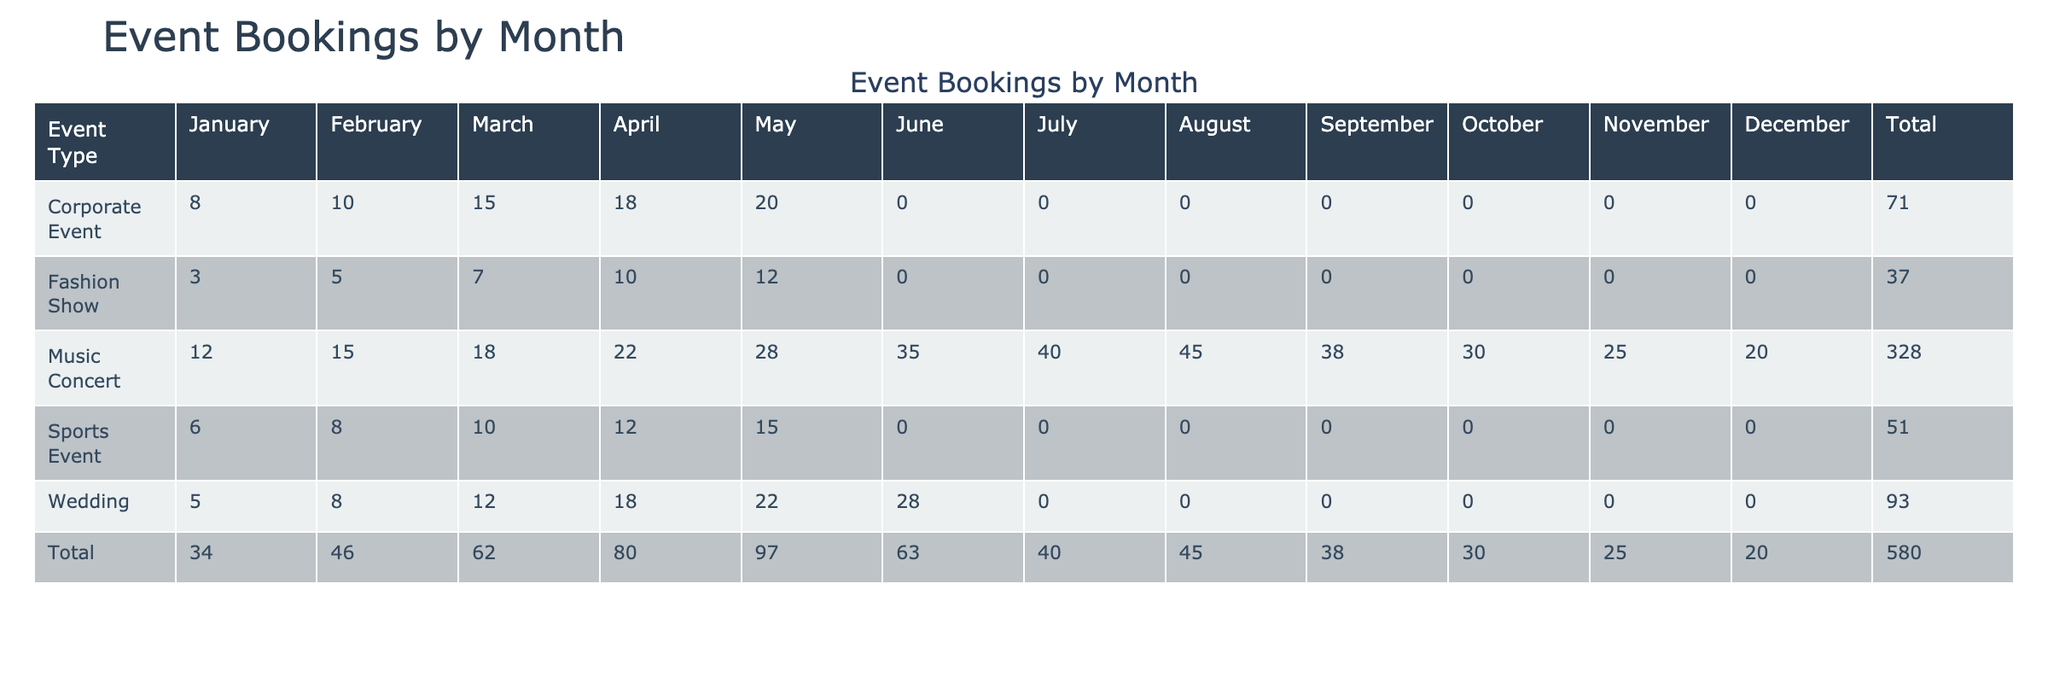What is the total number of bookings for music concerts in June? The table shows that in June, there were 35 bookings for music concerts listed under that month.
Answer: 35 Which event type had the highest total revenue across all months? By summing the revenue for each event type, we find that music concerts generated the most revenue, totaling 365,000, compared to weddings (225,000), corporate events (204,000), fashion shows (94,000), and sports events (77,000).
Answer: Music Concert How many more bookings were there for music concerts than weddings in October? In October, music concerts had 30 bookings, while weddings had 0. The difference is 30 - 0 = 30.
Answer: 30 What was the average number of bookings for corporate events in the months listed? There are 6 months of data for corporate events with a total of 81 bookings (8 + 10 + 15 + 18 + 20 + 10). The average is 81 divided by 6, which gives us 13.5.
Answer: 13.5 Did the bookings for fashion shows ever exceed 10 in any month? Checking the fashion show data, the highest number of bookings in any month was 12 in May, which indicates that they did exceed 10.
Answer: Yes In which month did music concerts have the highest number of bookings? By looking at the music concert data for each month, August shows the highest number of bookings with 45.
Answer: August What was the total number of bookings for sports events from January to May? The bookings for sports events during that period were: 6 (January) + 8 (February) + 10 (March) + 12 (April) + 15 (May) = 51.
Answer: 51 How does the total revenue from weddings compare with that from sports events? The total revenue for weddings is 225,000, while for sports events it is 77,000. This means weddings had significantly more revenue, with a difference of 148,000.
Answer: Weddings had more revenue In which city were the most bookings for music concerts made in June? Referring to the data, the city with the most bookings for music concerts in June is London, where 35 bookings were made.
Answer: London 